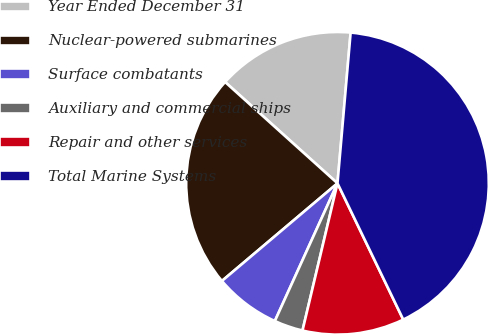Convert chart to OTSL. <chart><loc_0><loc_0><loc_500><loc_500><pie_chart><fcel>Year Ended December 31<fcel>Nuclear-powered submarines<fcel>Surface combatants<fcel>Auxiliary and commercial ships<fcel>Repair and other services<fcel>Total Marine Systems<nl><fcel>14.71%<fcel>22.84%<fcel>7.04%<fcel>3.08%<fcel>10.87%<fcel>41.46%<nl></chart> 